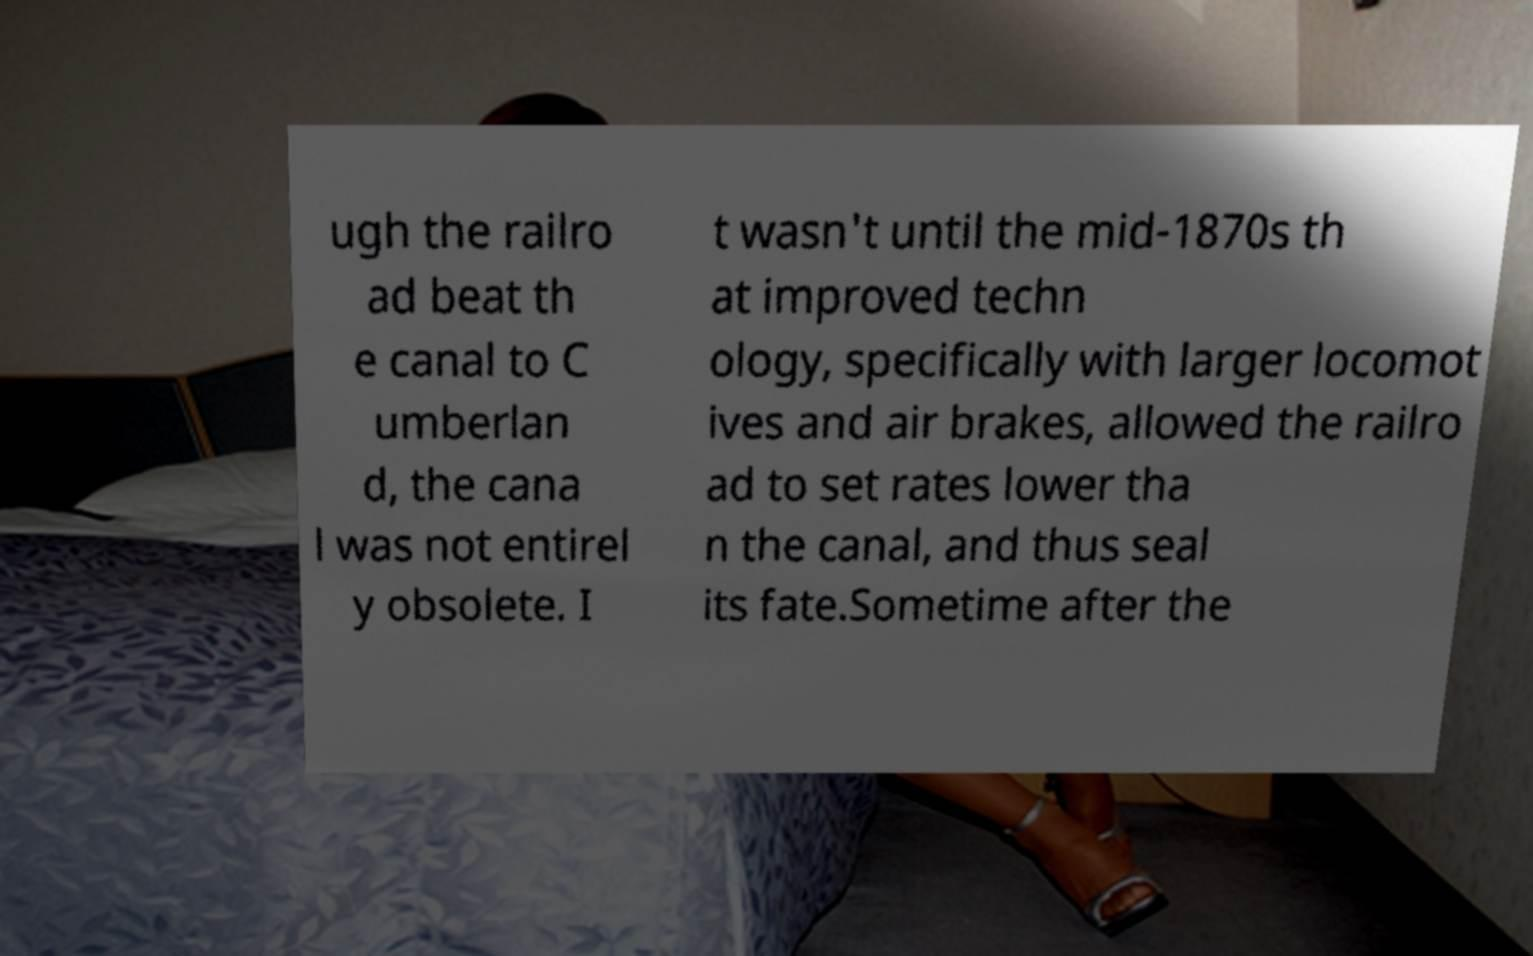Please read and relay the text visible in this image. What does it say? ugh the railro ad beat th e canal to C umberlan d, the cana l was not entirel y obsolete. I t wasn't until the mid-1870s th at improved techn ology, specifically with larger locomot ives and air brakes, allowed the railro ad to set rates lower tha n the canal, and thus seal its fate.Sometime after the 